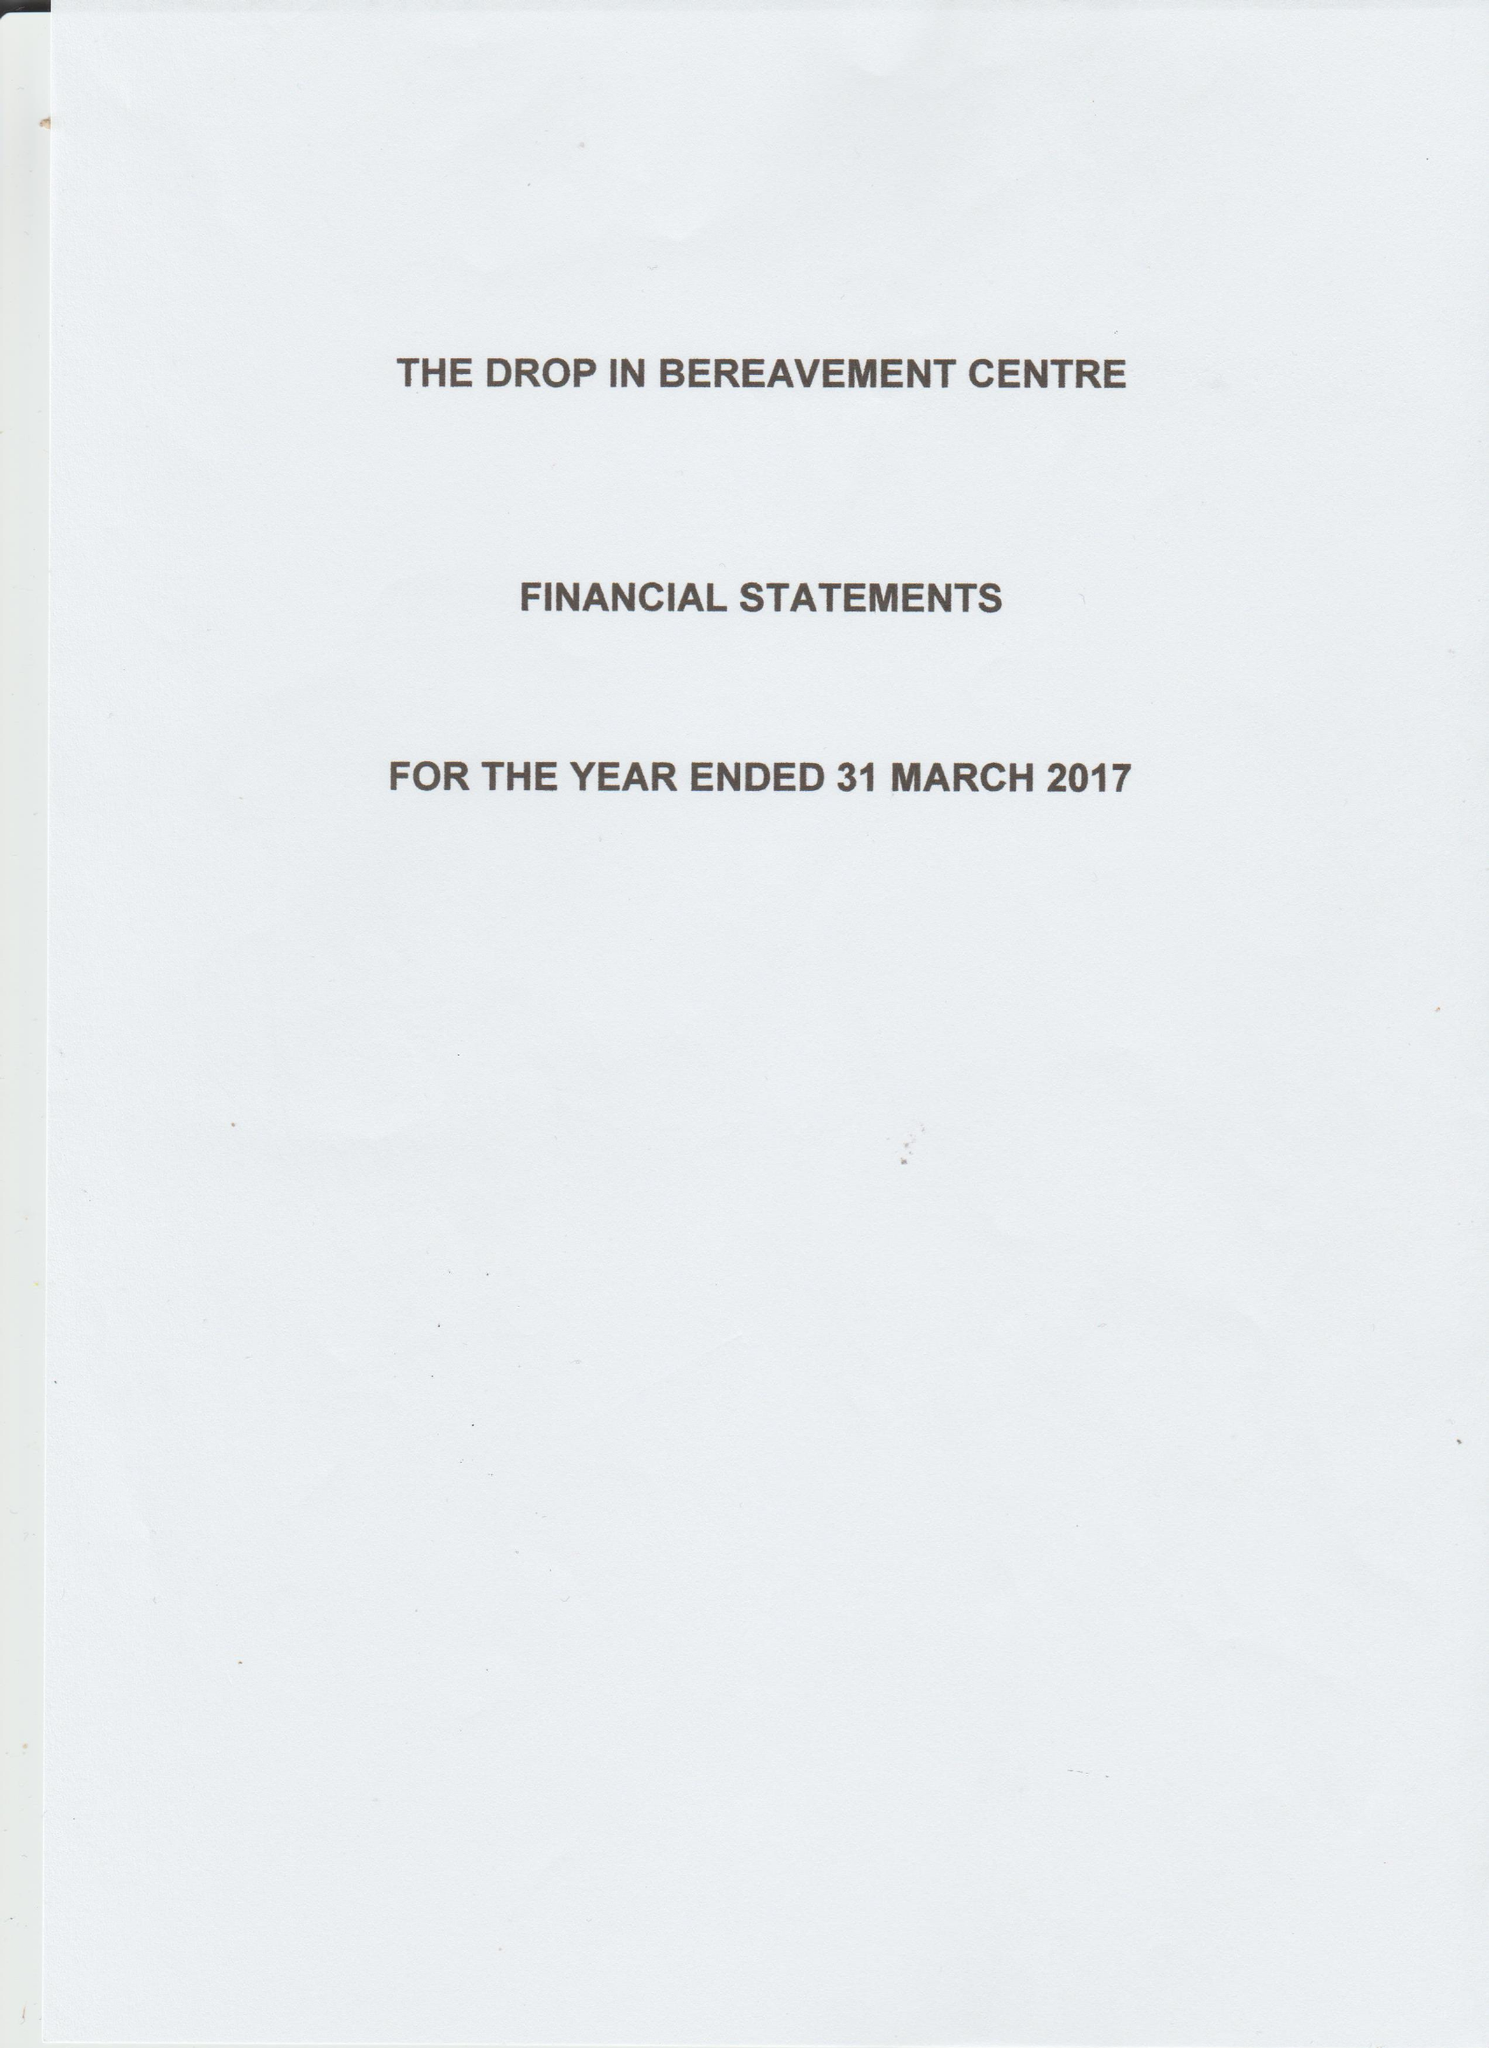What is the value for the address__post_town?
Answer the question using a single word or phrase. LONDON 